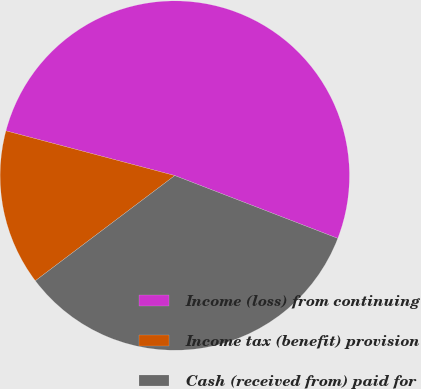<chart> <loc_0><loc_0><loc_500><loc_500><pie_chart><fcel>Income (loss) from continuing<fcel>Income tax (benefit) provision<fcel>Cash (received from) paid for<nl><fcel>51.73%<fcel>14.41%<fcel>33.86%<nl></chart> 